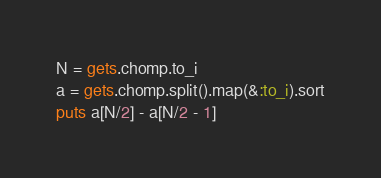Convert code to text. <code><loc_0><loc_0><loc_500><loc_500><_Ruby_>N = gets.chomp.to_i
a = gets.chomp.split().map(&:to_i).sort
puts a[N/2] - a[N/2 - 1]
</code> 